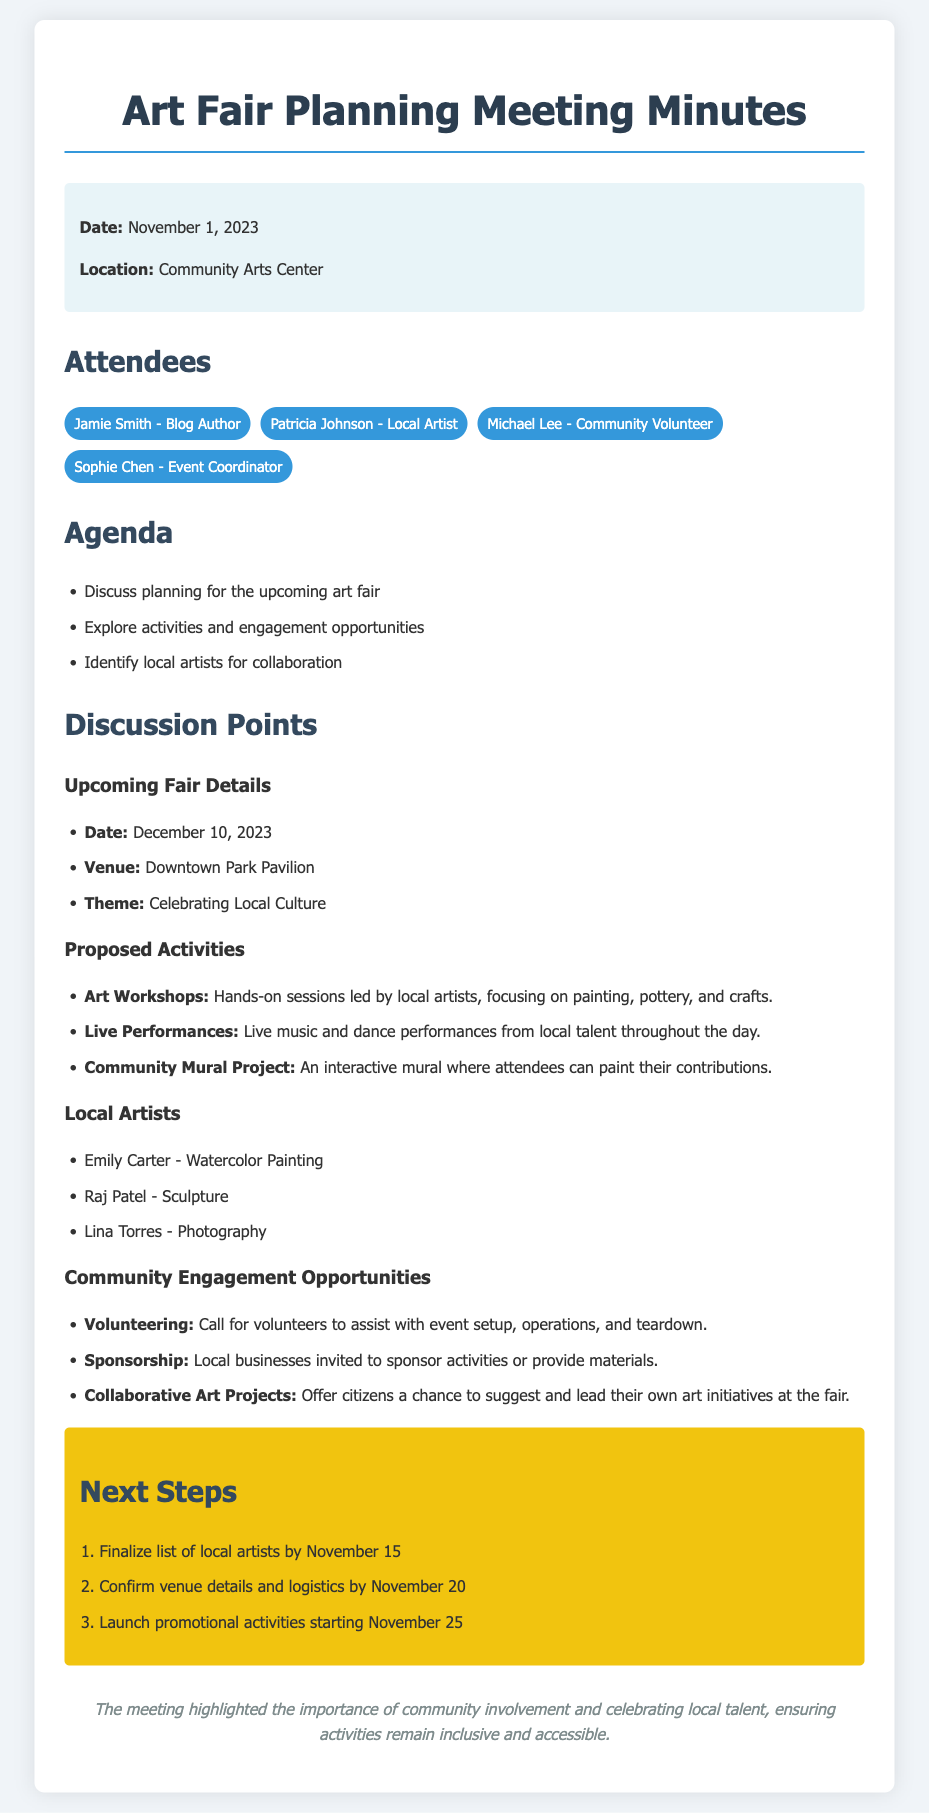what is the date of the meeting? The date of the meeting is clearly stated at the beginning of the document under the highlighted section.
Answer: November 1, 2023 where is the art fair taking place? The venue for the art fair is specified in the Upcoming Fair Details section.
Answer: Downtown Park Pavilion what is the theme of the art fair? The theme of the art fair is mentioned along with the date and venue.
Answer: Celebrating Local Culture who is leading the art workshops? The responsibility for the art workshops is noted in the Proposed Activities section, indicating local artists will lead them.
Answer: local artists what is one of the community engagement opportunities mentioned? This is found in the Community Engagement Opportunities section, which lists multiple items.
Answer: Volunteering when is the finalization date for the list of local artists? A specific date for finalizing the local artists is given in the Next Steps section.
Answer: November 15 how many proposed activities are listed? The Proposed Activities section includes a certain number of activities, which can be counted.
Answer: 3 who is a local artist specializing in photography? The local artists section includes the names and their specialties; this is one of them.
Answer: Lina Torres what is the main goal of the meeting? The conclusion at the end summarizes the main goal discussed during the meeting.
Answer: community involvement 